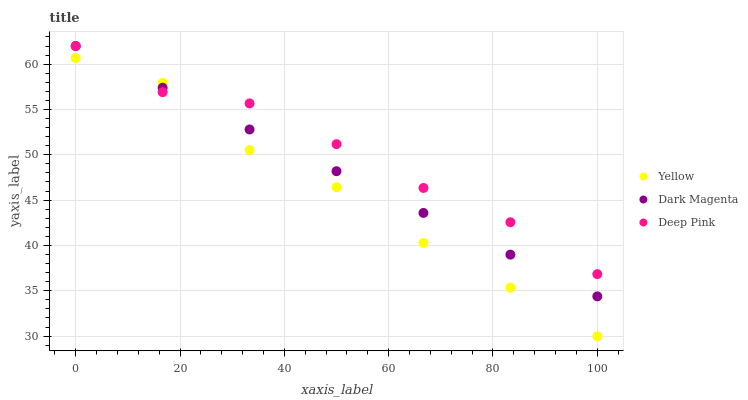Does Yellow have the minimum area under the curve?
Answer yes or no. Yes. Does Deep Pink have the maximum area under the curve?
Answer yes or no. Yes. Does Dark Magenta have the minimum area under the curve?
Answer yes or no. No. Does Dark Magenta have the maximum area under the curve?
Answer yes or no. No. Is Dark Magenta the smoothest?
Answer yes or no. Yes. Is Yellow the roughest?
Answer yes or no. Yes. Is Yellow the smoothest?
Answer yes or no. No. Is Dark Magenta the roughest?
Answer yes or no. No. Does Yellow have the lowest value?
Answer yes or no. Yes. Does Dark Magenta have the lowest value?
Answer yes or no. No. Does Dark Magenta have the highest value?
Answer yes or no. Yes. Does Yellow have the highest value?
Answer yes or no. No. Does Yellow intersect Deep Pink?
Answer yes or no. Yes. Is Yellow less than Deep Pink?
Answer yes or no. No. Is Yellow greater than Deep Pink?
Answer yes or no. No. 